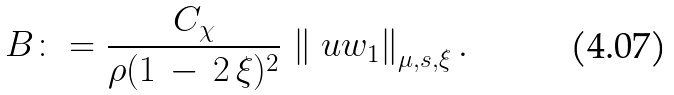Convert formula to latex. <formula><loc_0><loc_0><loc_500><loc_500>B \colon = \frac { C _ { \chi } } { \rho ( 1 \, - \, 2 \, \xi ) ^ { 2 } } \, \left \| \ u w _ { 1 } \right \| _ { \mu , s , \xi } .</formula> 